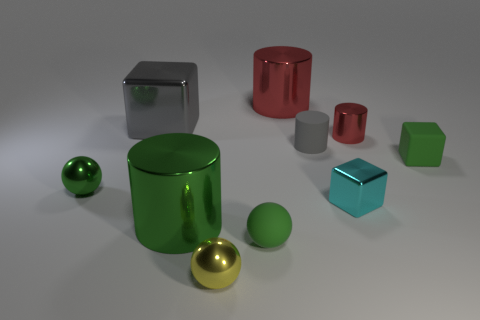Subtract all matte cubes. How many cubes are left? 2 Subtract 3 cylinders. How many cylinders are left? 1 Subtract all green cylinders. How many cylinders are left? 3 Subtract all cylinders. How many objects are left? 6 Add 4 yellow balls. How many yellow balls are left? 5 Add 4 tiny green spheres. How many tiny green spheres exist? 6 Subtract 1 cyan blocks. How many objects are left? 9 Subtract all gray balls. Subtract all brown cylinders. How many balls are left? 3 Subtract all gray cylinders. How many blue spheres are left? 0 Subtract all yellow cylinders. Subtract all big red cylinders. How many objects are left? 9 